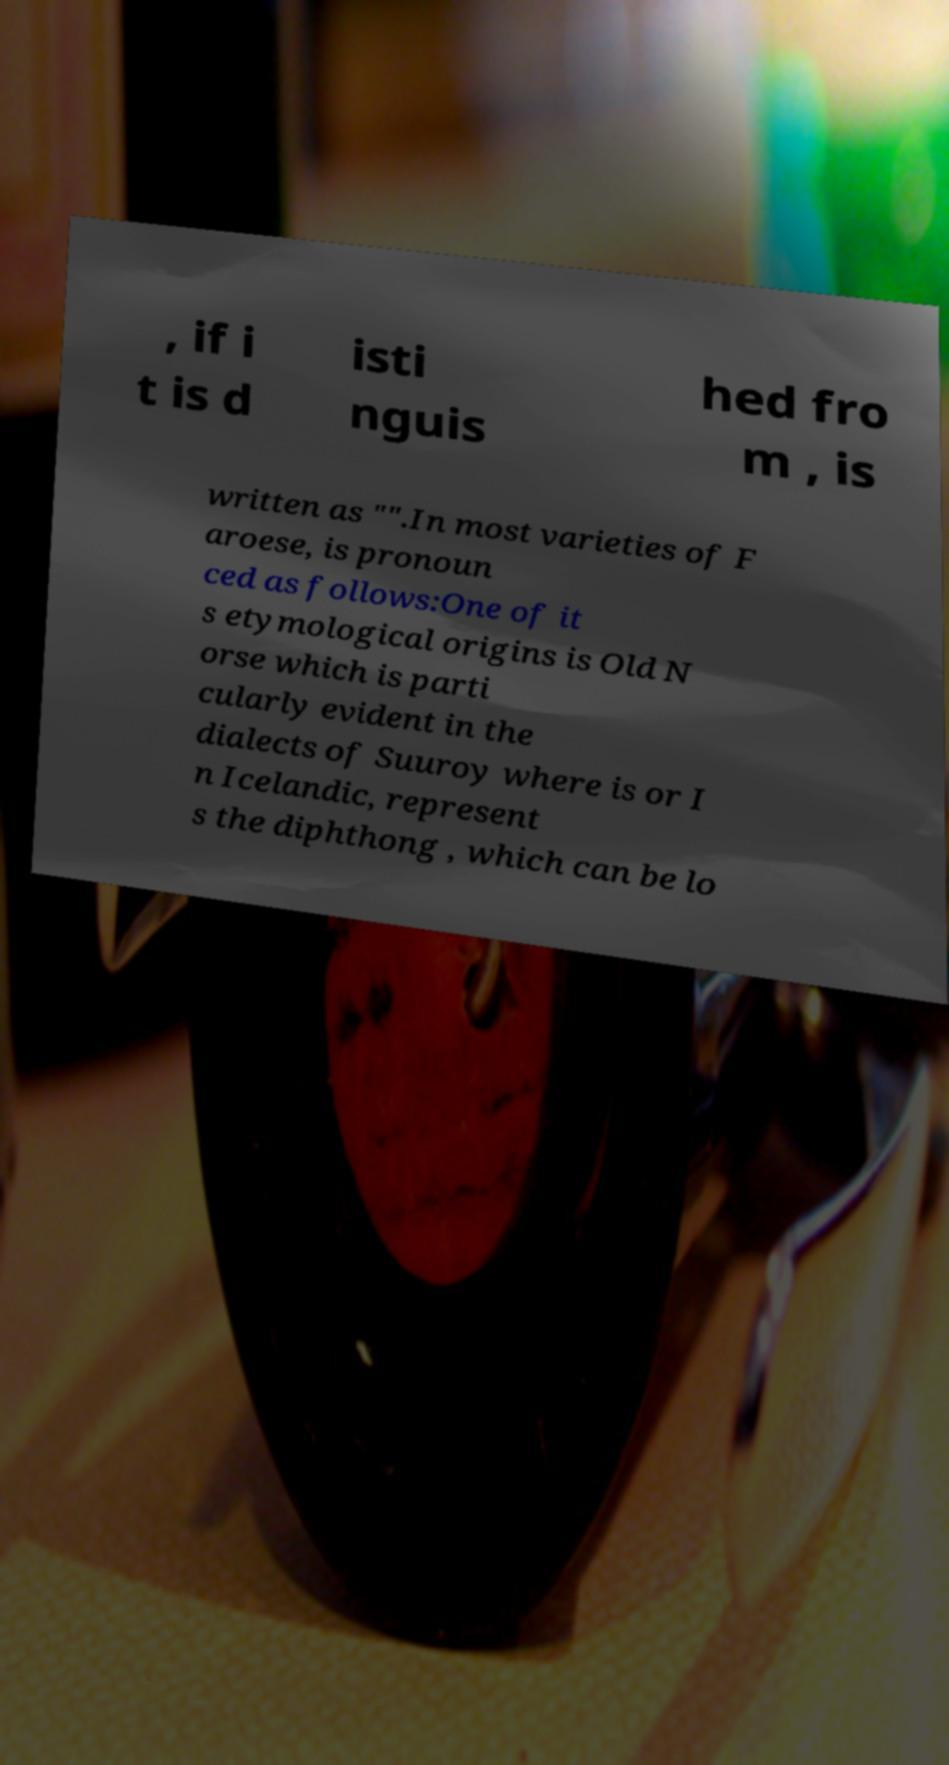Please identify and transcribe the text found in this image. , if i t is d isti nguis hed fro m , is written as "".In most varieties of F aroese, is pronoun ced as follows:One of it s etymological origins is Old N orse which is parti cularly evident in the dialects of Suuroy where is or I n Icelandic, represent s the diphthong , which can be lo 